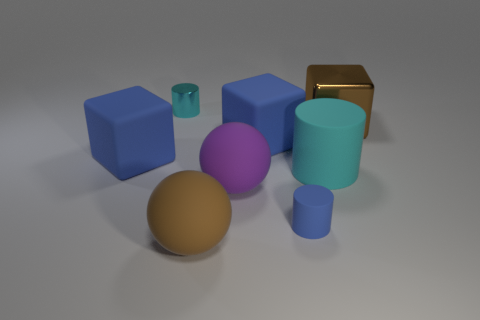There is a large block that is the same material as the tiny cyan cylinder; what color is it? The large block that shares the same material as the tiny cyan cylinder is not brown, as previously stated. In fact, based on the provided image, there is no large block with the same appearance as the tiny cyan cylinder. The tiny cylinder is a unique object in terms of color and material properties compared to the larger blocks in the image. 